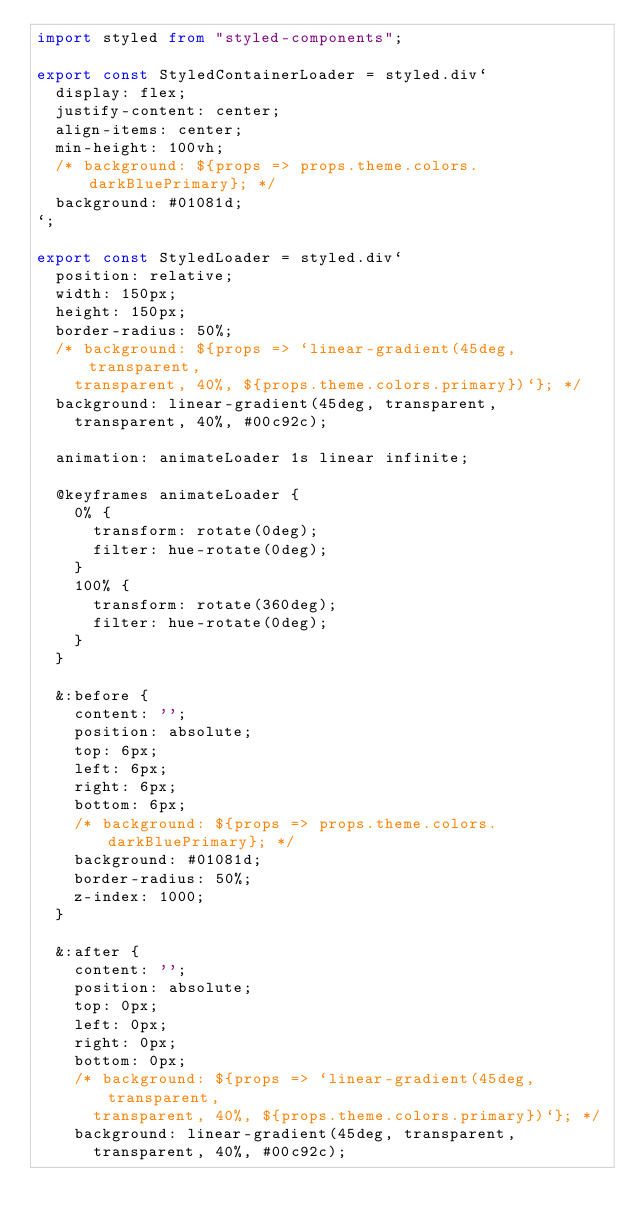<code> <loc_0><loc_0><loc_500><loc_500><_TypeScript_>import styled from "styled-components";

export const StyledContainerLoader = styled.div`
  display: flex;
  justify-content: center;
  align-items: center;
  min-height: 100vh;
  /* background: ${props => props.theme.colors.darkBluePrimary}; */
  background: #01081d;
`;

export const StyledLoader = styled.div`
  position: relative;
  width: 150px;
  height: 150px;
  border-radius: 50%;
  /* background: ${props => `linear-gradient(45deg, transparent,
    transparent, 40%, ${props.theme.colors.primary})`}; */
  background: linear-gradient(45deg, transparent,
    transparent, 40%, #00c92c);

  animation: animateLoader 1s linear infinite;

  @keyframes animateLoader {
    0% {
      transform: rotate(0deg);
      filter: hue-rotate(0deg);
    }
    100% {
      transform: rotate(360deg);
      filter: hue-rotate(0deg);
    }
  }

  &:before {
    content: '';
    position: absolute;
    top: 6px;
    left: 6px;
    right: 6px;
    bottom: 6px;
    /* background: ${props => props.theme.colors.darkBluePrimary}; */
    background: #01081d;
    border-radius: 50%;
    z-index: 1000;
  }

  &:after {
    content: '';
    position: absolute;
    top: 0px;
    left: 0px;
    right: 0px;
    bottom: 0px;
    /* background: ${props => `linear-gradient(45deg, transparent,
      transparent, 40%, ${props.theme.colors.primary})`}; */
    background: linear-gradient(45deg, transparent,
      transparent, 40%, #00c92c);</code> 